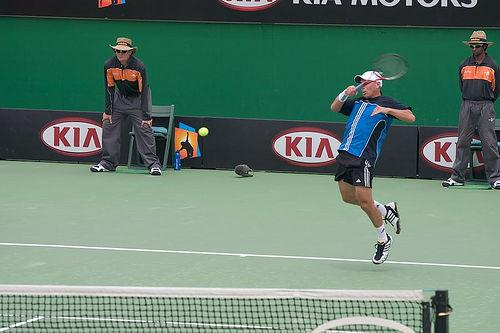What did the man in the blue shirt just do? hit ball 